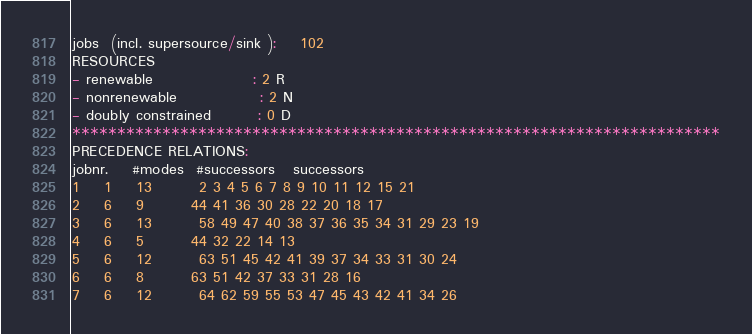<code> <loc_0><loc_0><loc_500><loc_500><_ObjectiveC_>jobs  (incl. supersource/sink ):	102
RESOURCES
- renewable                 : 2 R
- nonrenewable              : 2 N
- doubly constrained        : 0 D
************************************************************************
PRECEDENCE RELATIONS:
jobnr.    #modes  #successors   successors
1	1	13		2 3 4 5 6 7 8 9 10 11 12 15 21 
2	6	9		44 41 36 30 28 22 20 18 17 
3	6	13		58 49 47 40 38 37 36 35 34 31 29 23 19 
4	6	5		44 32 22 14 13 
5	6	12		63 51 45 42 41 39 37 34 33 31 30 24 
6	6	8		63 51 42 37 33 31 28 16 
7	6	12		64 62 59 55 53 47 45 43 42 41 34 26 </code> 